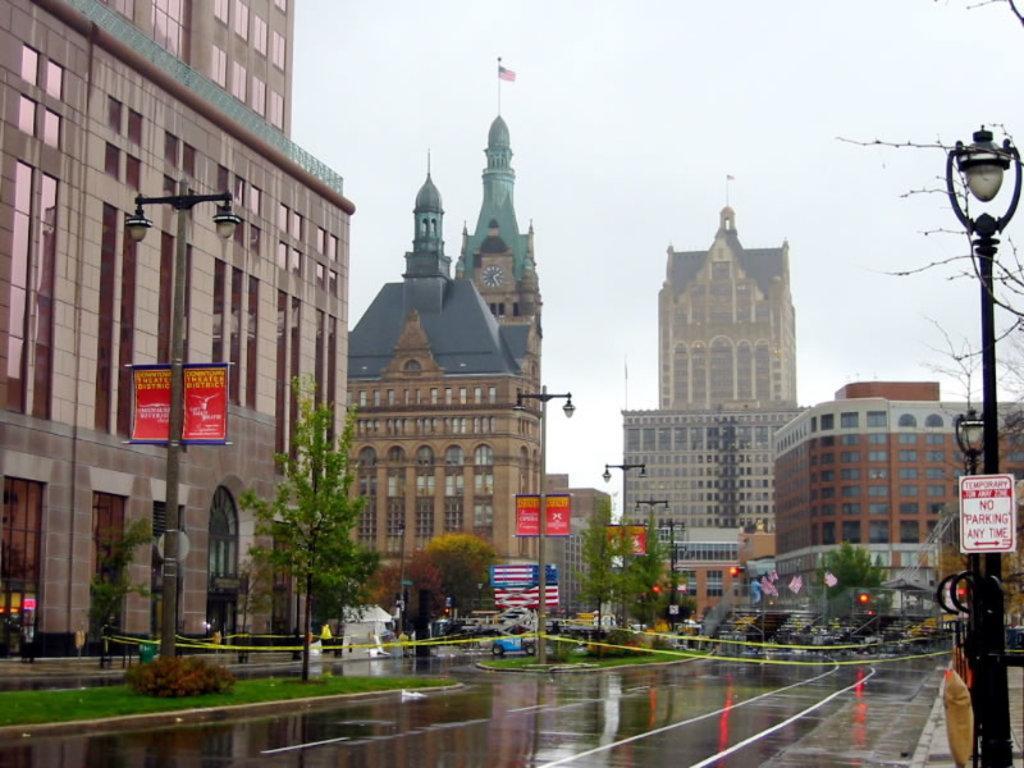How would you summarize this image in a sentence or two? In the image there is a road and around the road there are street lights, behind the street lights there are many buildings and there are few trees in front of those buildings, there are also traffic signal lights and there is a flag behind one of the street light. 